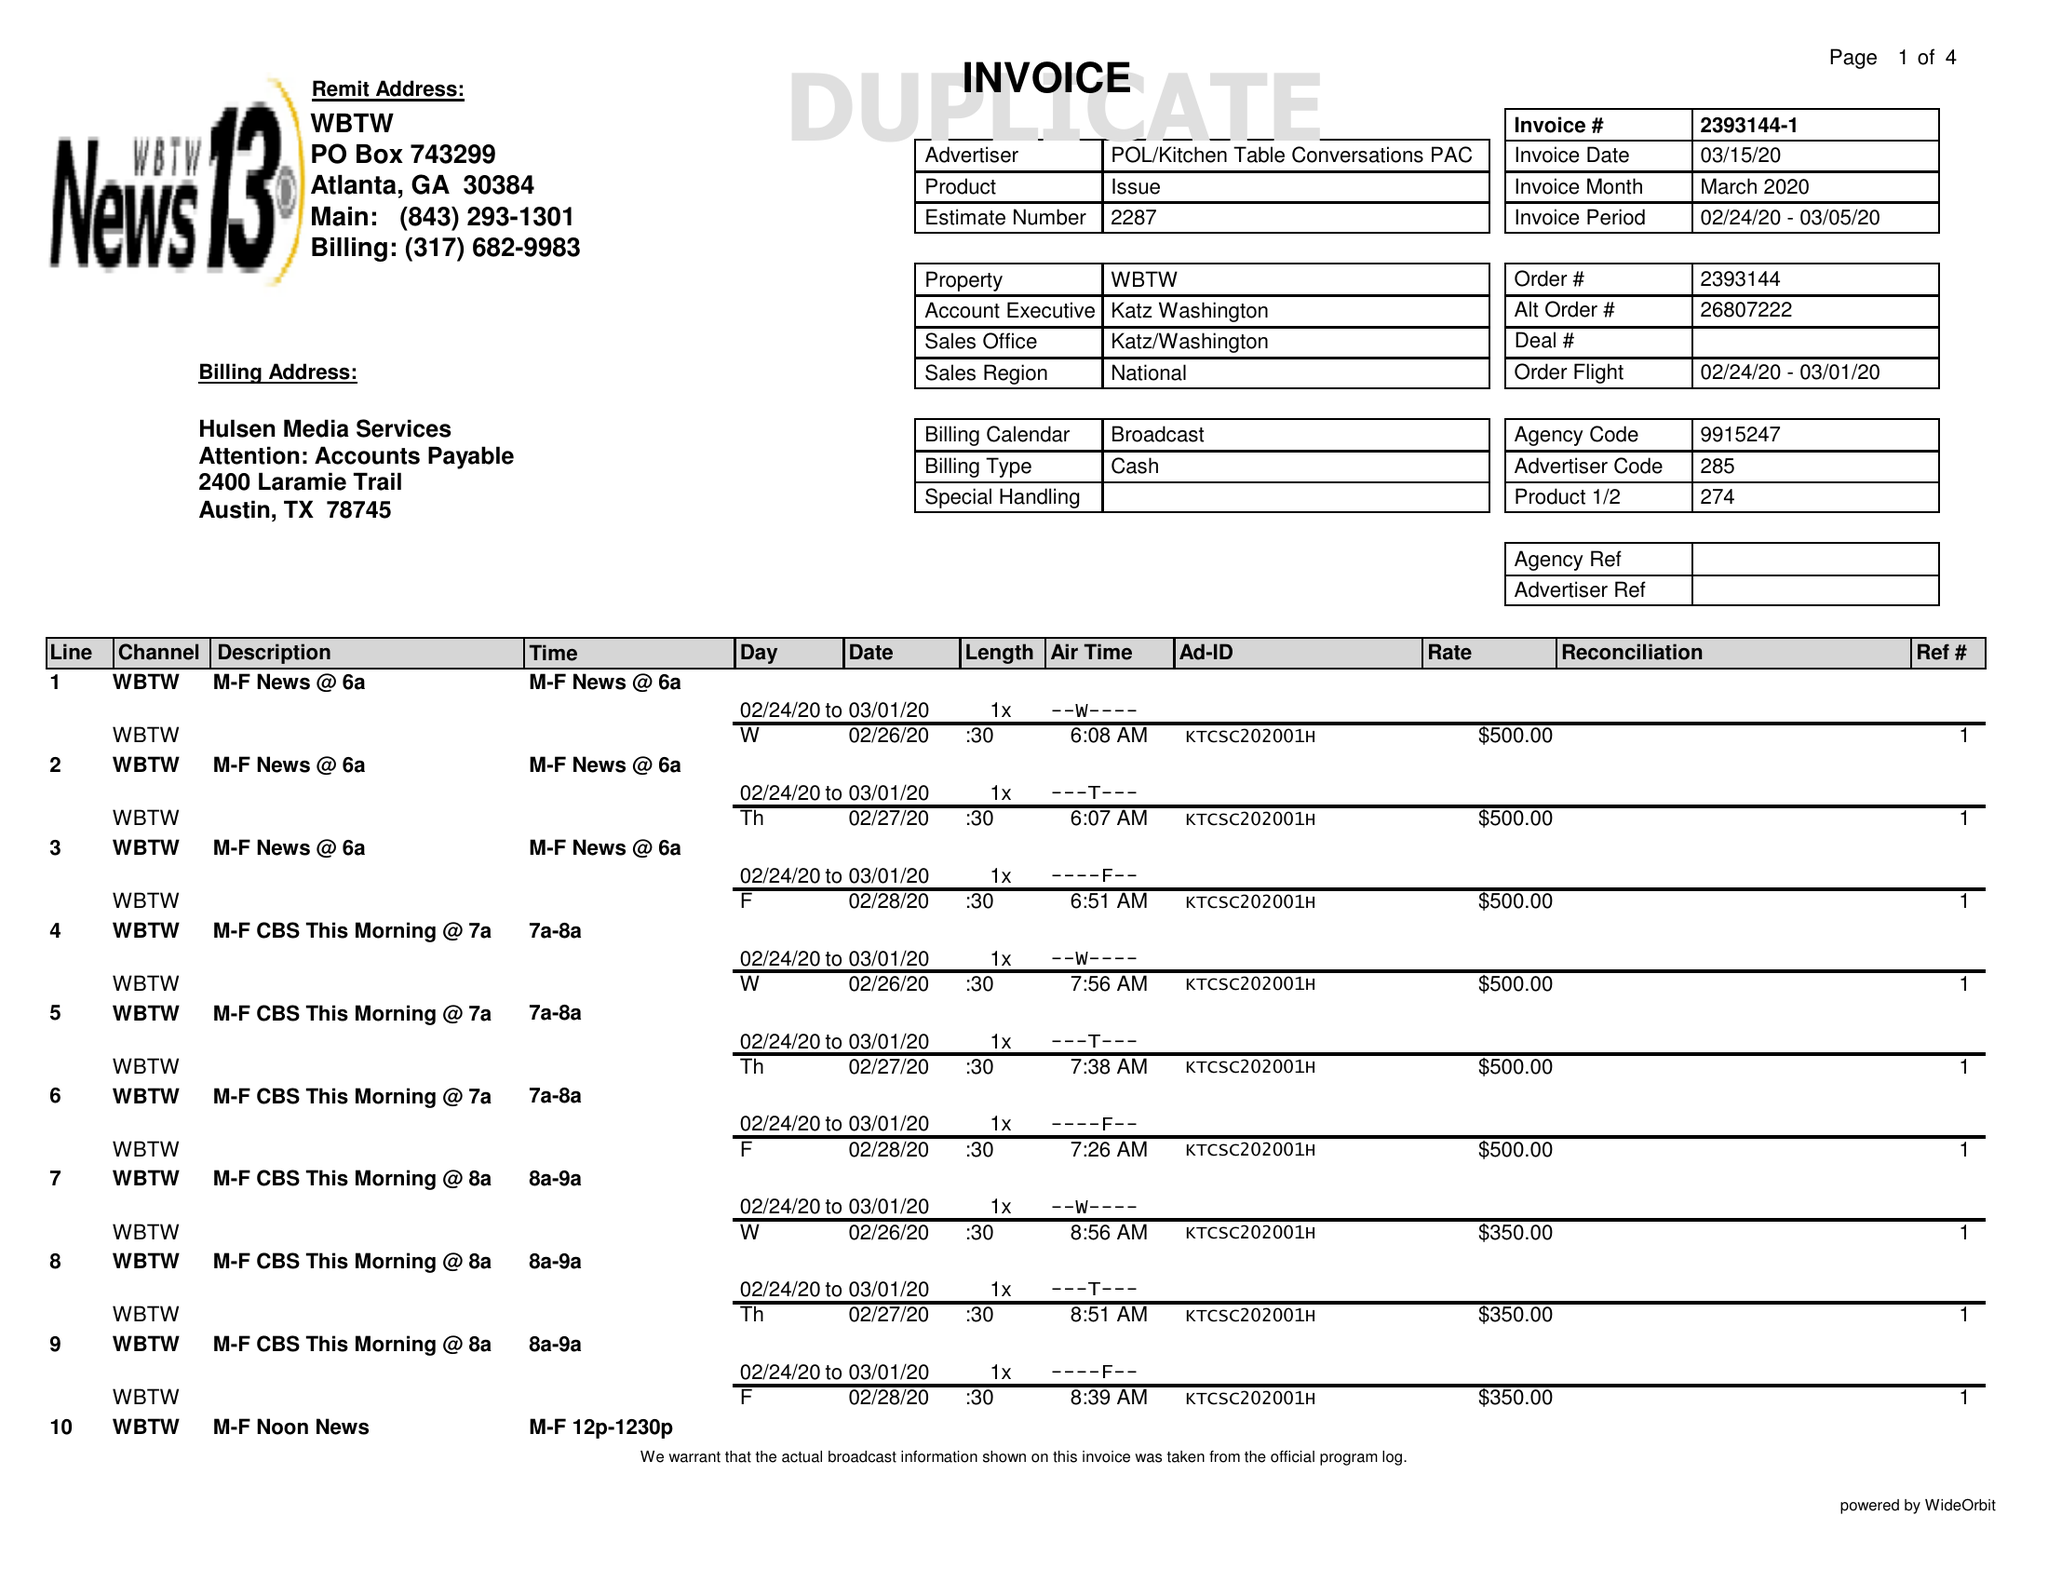What is the value for the contract_num?
Answer the question using a single word or phrase. 2393144 